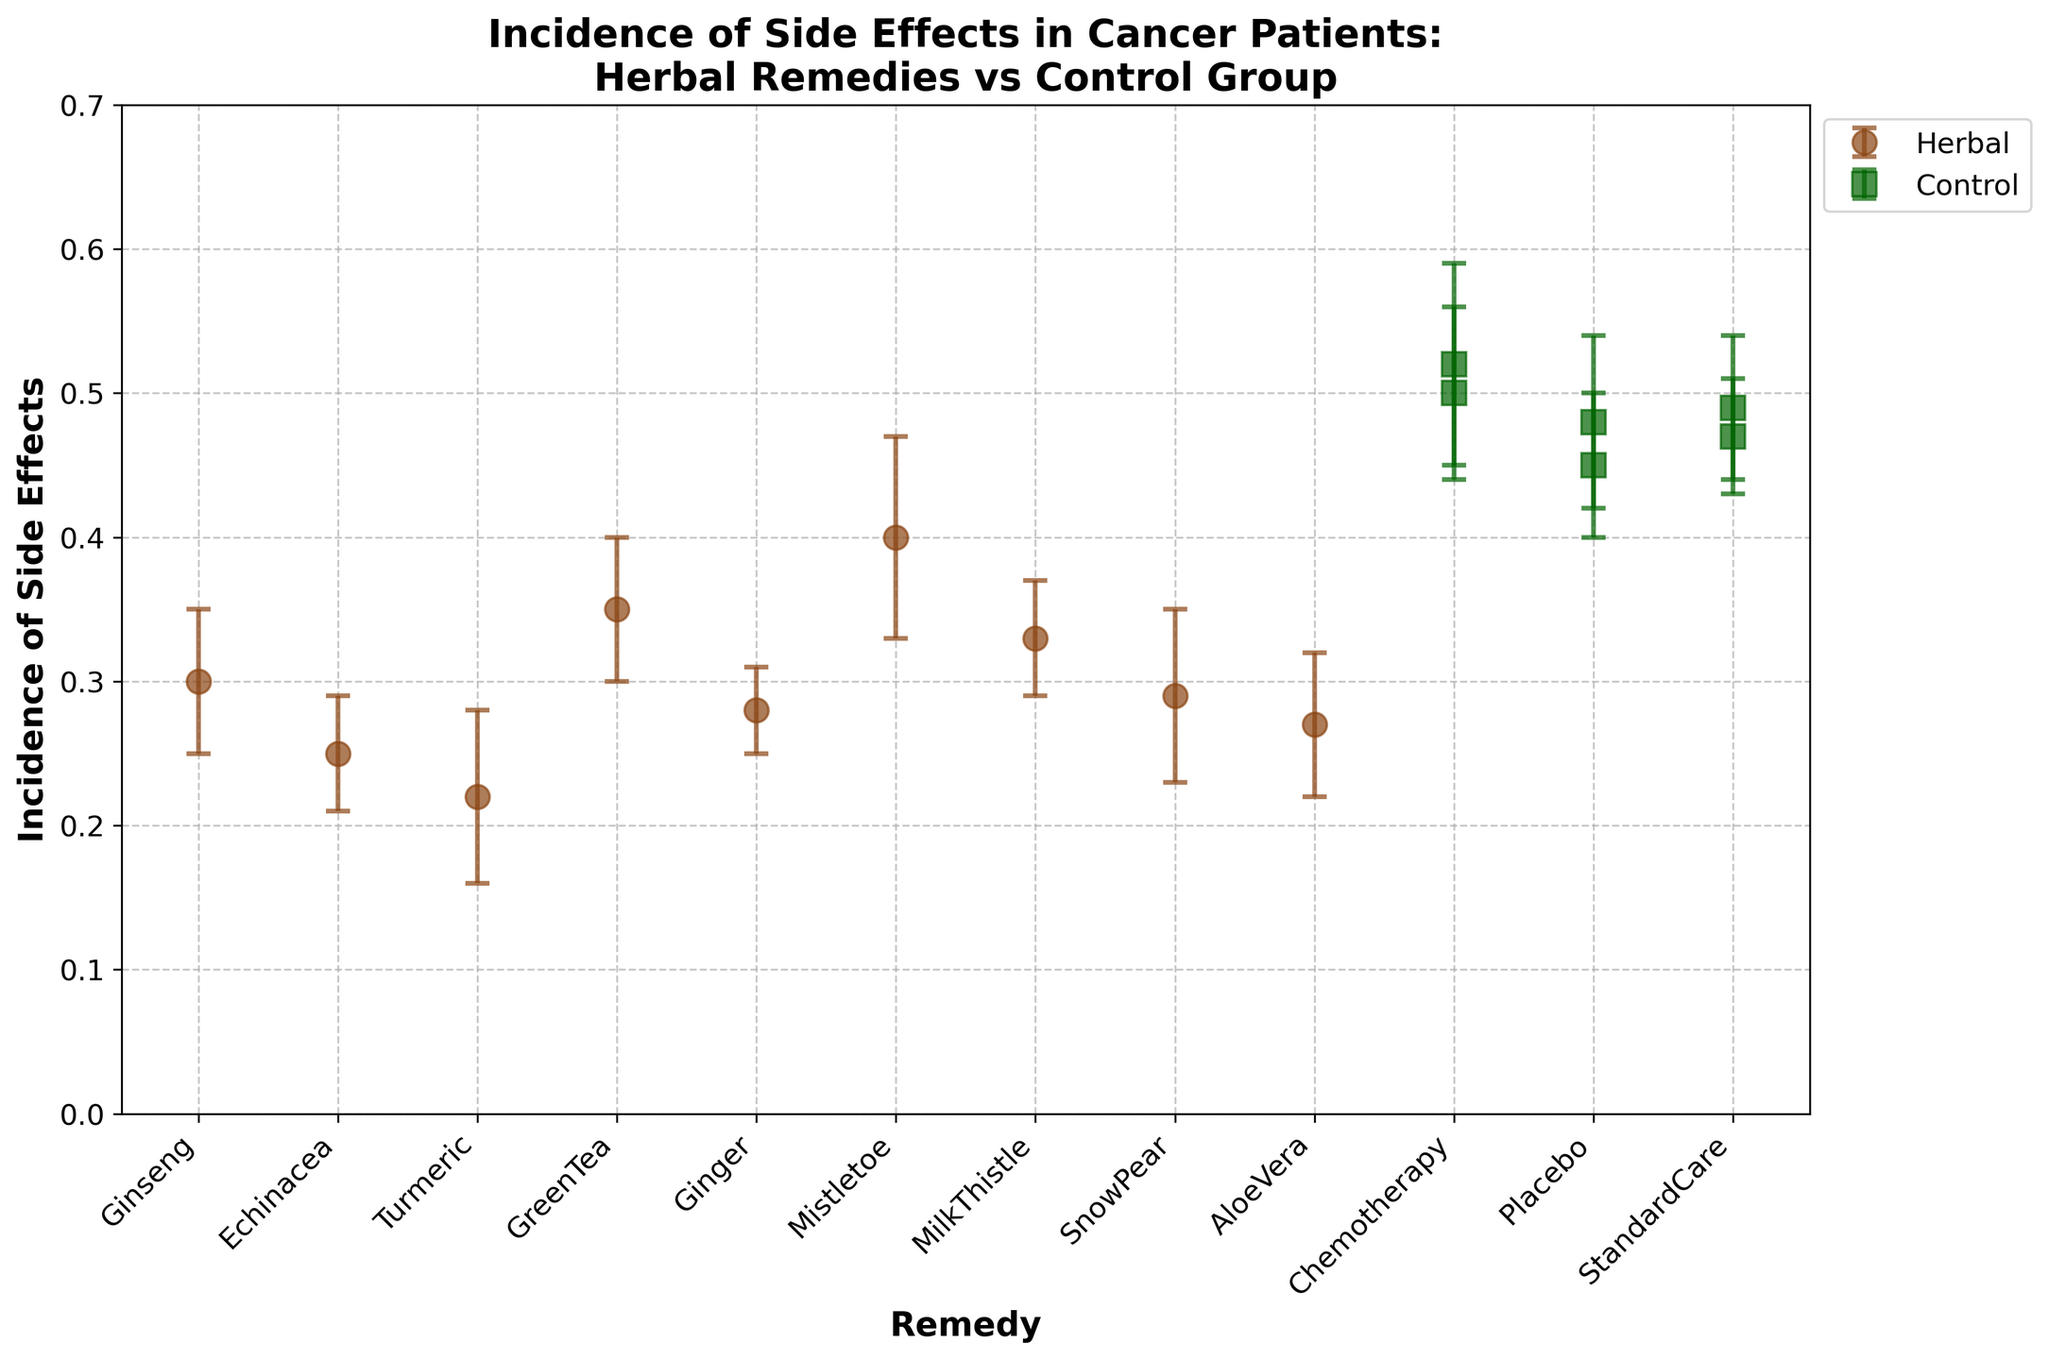What is the title of the figure? The title of the figure is written at the top, it reads "Incidence of Side Effects in Cancer Patients: Herbal Remedies vs Control Group".
Answer: Incidence of Side Effects in Cancer Patients: Herbal Remedies vs Control Group How many herbs were tested in the figure? Count the number of unique herbal remedy names on the x-axis.
Answer: 8 Which group has the higher average incidence of side effects, Herbal or Control? Calculate the average incidence of side effects for the Herbal group and the Control group separately, then compare them.
Answer: Control What is the incidence of side effects for the herbal remedy "Green Tea"? Find the data point labeled "Green Tea" on the x-axis and check its incidence value on the y-axis.
Answer: 0.35 What is the difference in the incidence of side effects between "Chemotherapy" and "Milk Thistle"? Check the incidence values for "Chemotherapy" and "Milk Thistle" and subtract the latter from the former.
Answer: 0.18 Which herbal remedy has the highest incidence of side effects? Identify the highest point among the Herbal group data points.
Answer: Mistletoe How do the error bars for "Placebo" compare with "Aloe Vera"? Compare the length of the error bars for "Placebo" and those for "Aloe Vera".
Answer: They are about the same length What is the range of incidence of side effects in the Herbal group? Identify the minimum and maximum incidence values in the Herbal group and calculate the difference.
Answer: 0.18 Is the highest incidence of side effects in the Control group higher than the highest in the Herbal group? Compare the highest incidence value in the Control group with the highest in the Herbal group.
Answer: Yes How does the incidence of side effects for "Echinacea" compare with "Turmeric"? Check the incidence values for both "Echinacea" and "Turmeric".
Answer: Echinacea is higher 